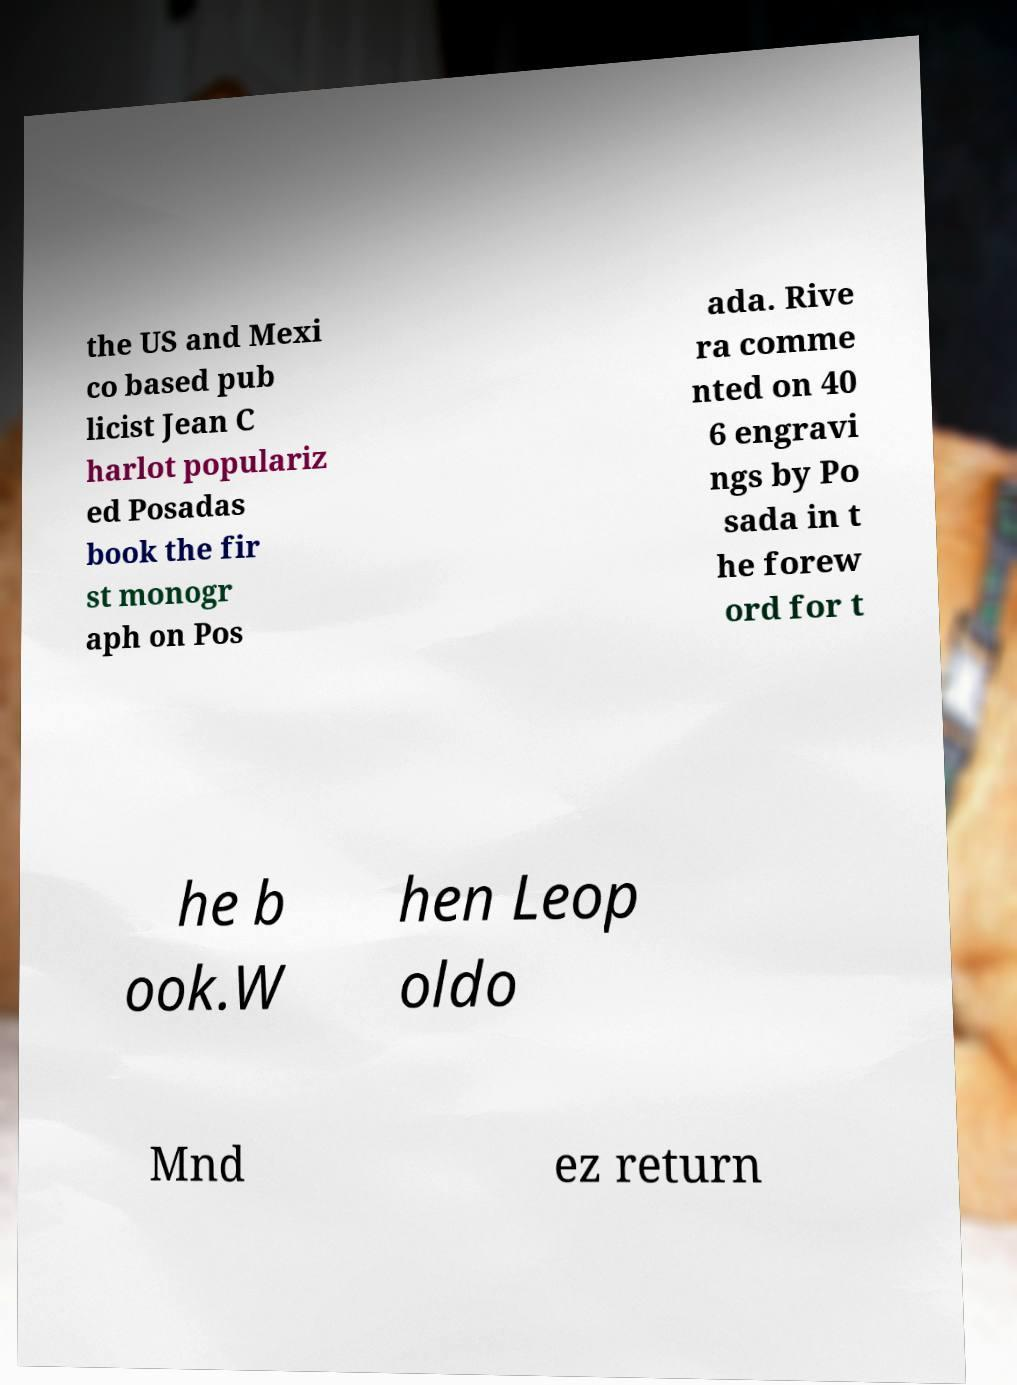For documentation purposes, I need the text within this image transcribed. Could you provide that? the US and Mexi co based pub licist Jean C harlot populariz ed Posadas book the fir st monogr aph on Pos ada. Rive ra comme nted on 40 6 engravi ngs by Po sada in t he forew ord for t he b ook.W hen Leop oldo Mnd ez return 